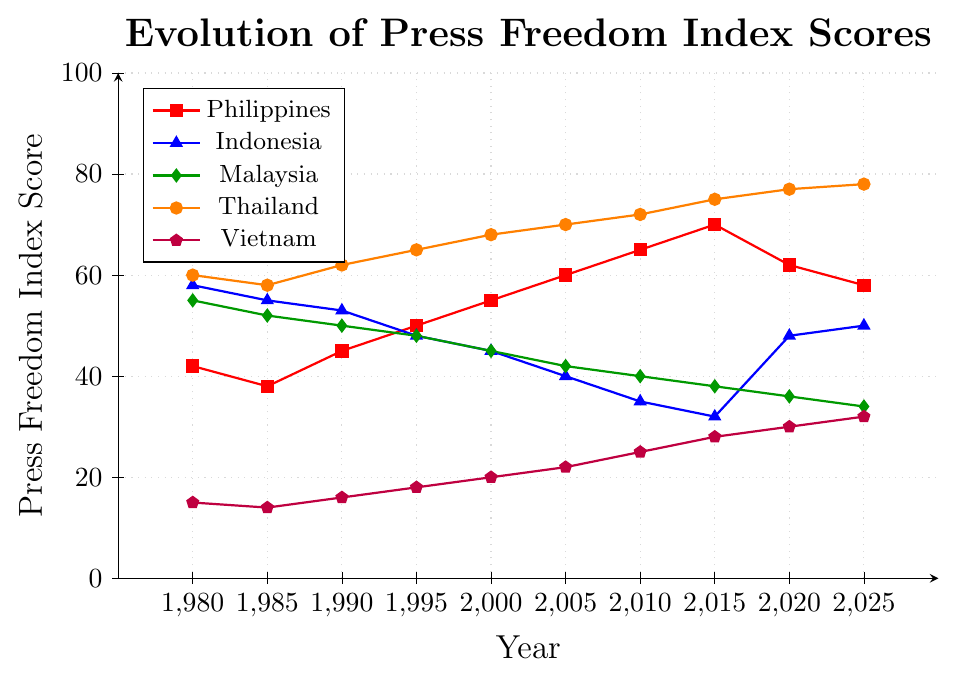What general trend does the Press Freedom Index Score show for the Philippines from 1980 to 2015? Between 1980 and 2015, the Philippines' score generally increased from 42 to 70. This indicates a declining state of press freedom over the years.
Answer: Increasing trend How did Thailand's Press Freedom Index Score change from 1980 to 2025? Thailand's score increased from 60 in 1980 to 78 in 2025, showing a steady decline in press freedom over the years.
Answer: Increased In which year did Indonesia have the lowest Press Freedom Index Score, and what was the score? Between 1980 and 2025, Indonesia had the lowest Press Freedom Index Score in 2015, with a score of 32.
Answer: 2015, 32 Compared to the Philippines, which country showed the most similar trend in Press Freedom Index from 1980 to 2025? From 1980 to 2025, Malaysia's trend showed the most similarity to the Philippines', as both countries followed a generally increasing trend with some fluctuations.
Answer: Malaysia Which country had the highest press freedom in 1980 and what was that score? Vietnam had the highest press freedom score in 1980, with a score of 15.
Answer: Vietnam, 15 How did the Press Freedom Index Score for the Philippines compare to Malaysia in the year 2020? In 2020, the Press Freedom Index Score for the Philippines was 62, while for Malaysia it was 36. The Philippines had a much higher score, indicating worse press freedom.
Answer: The Philippines had a higher score What was the average Press Freedom Index Score for Thailand over the observed years? Adding up Thailand's scores (60, 58, 62, 65, 68, 70, 72, 75, 77, 78) gives 685. Dividing by the number of years (10), the average score is 68.5.
Answer: 68.5 By how many points did Indonesia’s Press Freedom Index Score improve from 1980 to 2015? In 1980, Indonesia's score was 58. In 2015, it was 32. The score improved by 58 - 32 = 26 points.
Answer: 26 points What noticeable change occurred in the Press Freedom Index Score for the Philippines between 2015 and 2020? The score for the Philippines decreased from 70 in 2015 to 62 in 2020, indicating an improvement in press freedom.
Answer: Decreased by 8 points Considering the data up to 2025, which country showed the greatest improvement in Press Freedom Index Score since 1980? Vietnam showed the greatest improvement, with its score increasing from 15 in 1980 to 32 in 2025, an improvement of 17 points in terms of press freedom.
Answer: Vietnam 